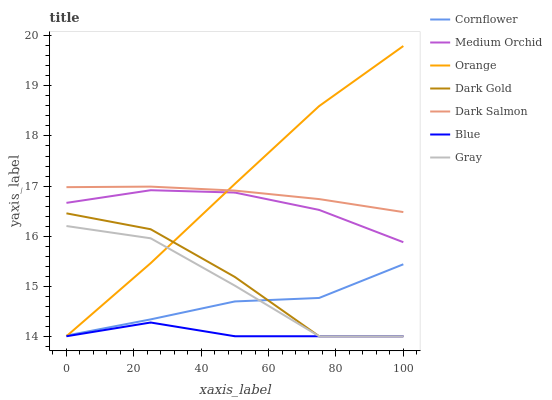Does Blue have the minimum area under the curve?
Answer yes or no. Yes. Does Orange have the maximum area under the curve?
Answer yes or no. Yes. Does Cornflower have the minimum area under the curve?
Answer yes or no. No. Does Cornflower have the maximum area under the curve?
Answer yes or no. No. Is Dark Salmon the smoothest?
Answer yes or no. Yes. Is Dark Gold the roughest?
Answer yes or no. Yes. Is Cornflower the smoothest?
Answer yes or no. No. Is Cornflower the roughest?
Answer yes or no. No. Does Blue have the lowest value?
Answer yes or no. Yes. Does Cornflower have the lowest value?
Answer yes or no. No. Does Orange have the highest value?
Answer yes or no. Yes. Does Cornflower have the highest value?
Answer yes or no. No. Is Blue less than Cornflower?
Answer yes or no. Yes. Is Dark Salmon greater than Cornflower?
Answer yes or no. Yes. Does Dark Gold intersect Gray?
Answer yes or no. Yes. Is Dark Gold less than Gray?
Answer yes or no. No. Is Dark Gold greater than Gray?
Answer yes or no. No. Does Blue intersect Cornflower?
Answer yes or no. No. 